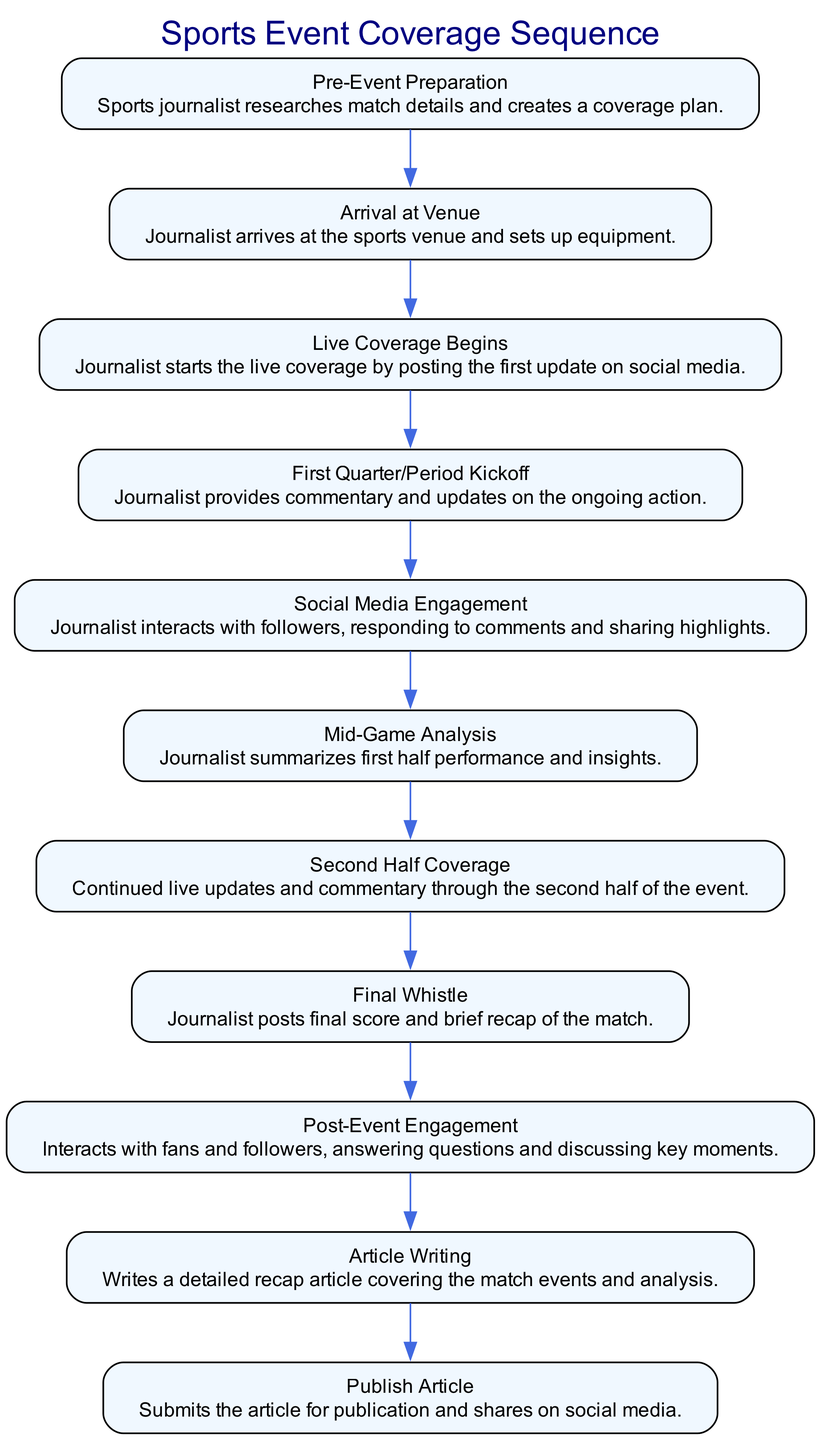What is the first event in the sequence? The first event listed in the sequence is "Pre-Event Preparation," which is the initial step taken by the sports journalist before the live event coverage begins.
Answer: Pre-Event Preparation How many total events are in the sequence? By counting each event listed in the sequence from "Pre-Event Preparation" to "Publish Article," there are a total of 11 events.
Answer: 11 Which event follows "Mid-Game Analysis"? The event that comes directly after "Mid-Game Analysis" is "Second Half Coverage," indicating a continuation of the live updates after the analysis.
Answer: Second Half Coverage What is the final event in the coverage sequence? The last event in the sequence is "Publish Article," which is the concluding action after all live coverage and post-event engagement activities.
Answer: Publish Article What type of engagement occurs during the "Social Media Engagement" event? During the "Social Media Engagement" event, the journalist actively interacts with followers by responding to comments and sharing highlights, emphasizing the engagement aspect of the coverage.
Answer: Interacts with followers What is the relationship between "Final Whistle" and "Post-Event Engagement"? "Final Whistle" leads directly to "Post-Event Engagement," as the journalist posts the final score and then continues to interact with fans regarding the match insights right after the game concludes.
Answer: Leads to What activity does the journalist perform immediately after the "Live Coverage Begins"? Immediately after "Live Coverage Begins," the journalist participates in the "First Quarter/Period Kickoff," providing commentary and updates about the ongoing sports action.
Answer: First Quarter/Period Kickoff Which event includes summarizing the first half performance? The event titled "Mid-Game Analysis" specifically involves summarizing the performance and insights from the first half of the game, indicating an assessment of the ongoing match.
Answer: Mid-Game Analysis Which two events are focused on fans’ interaction? The events "Social Media Engagement" and "Post-Event Engagement" both specifically focus on interacting with fans and followers, indicating a continuous engagement strategy throughout the live coverage.
Answer: Social Media Engagement, Post-Event Engagement 